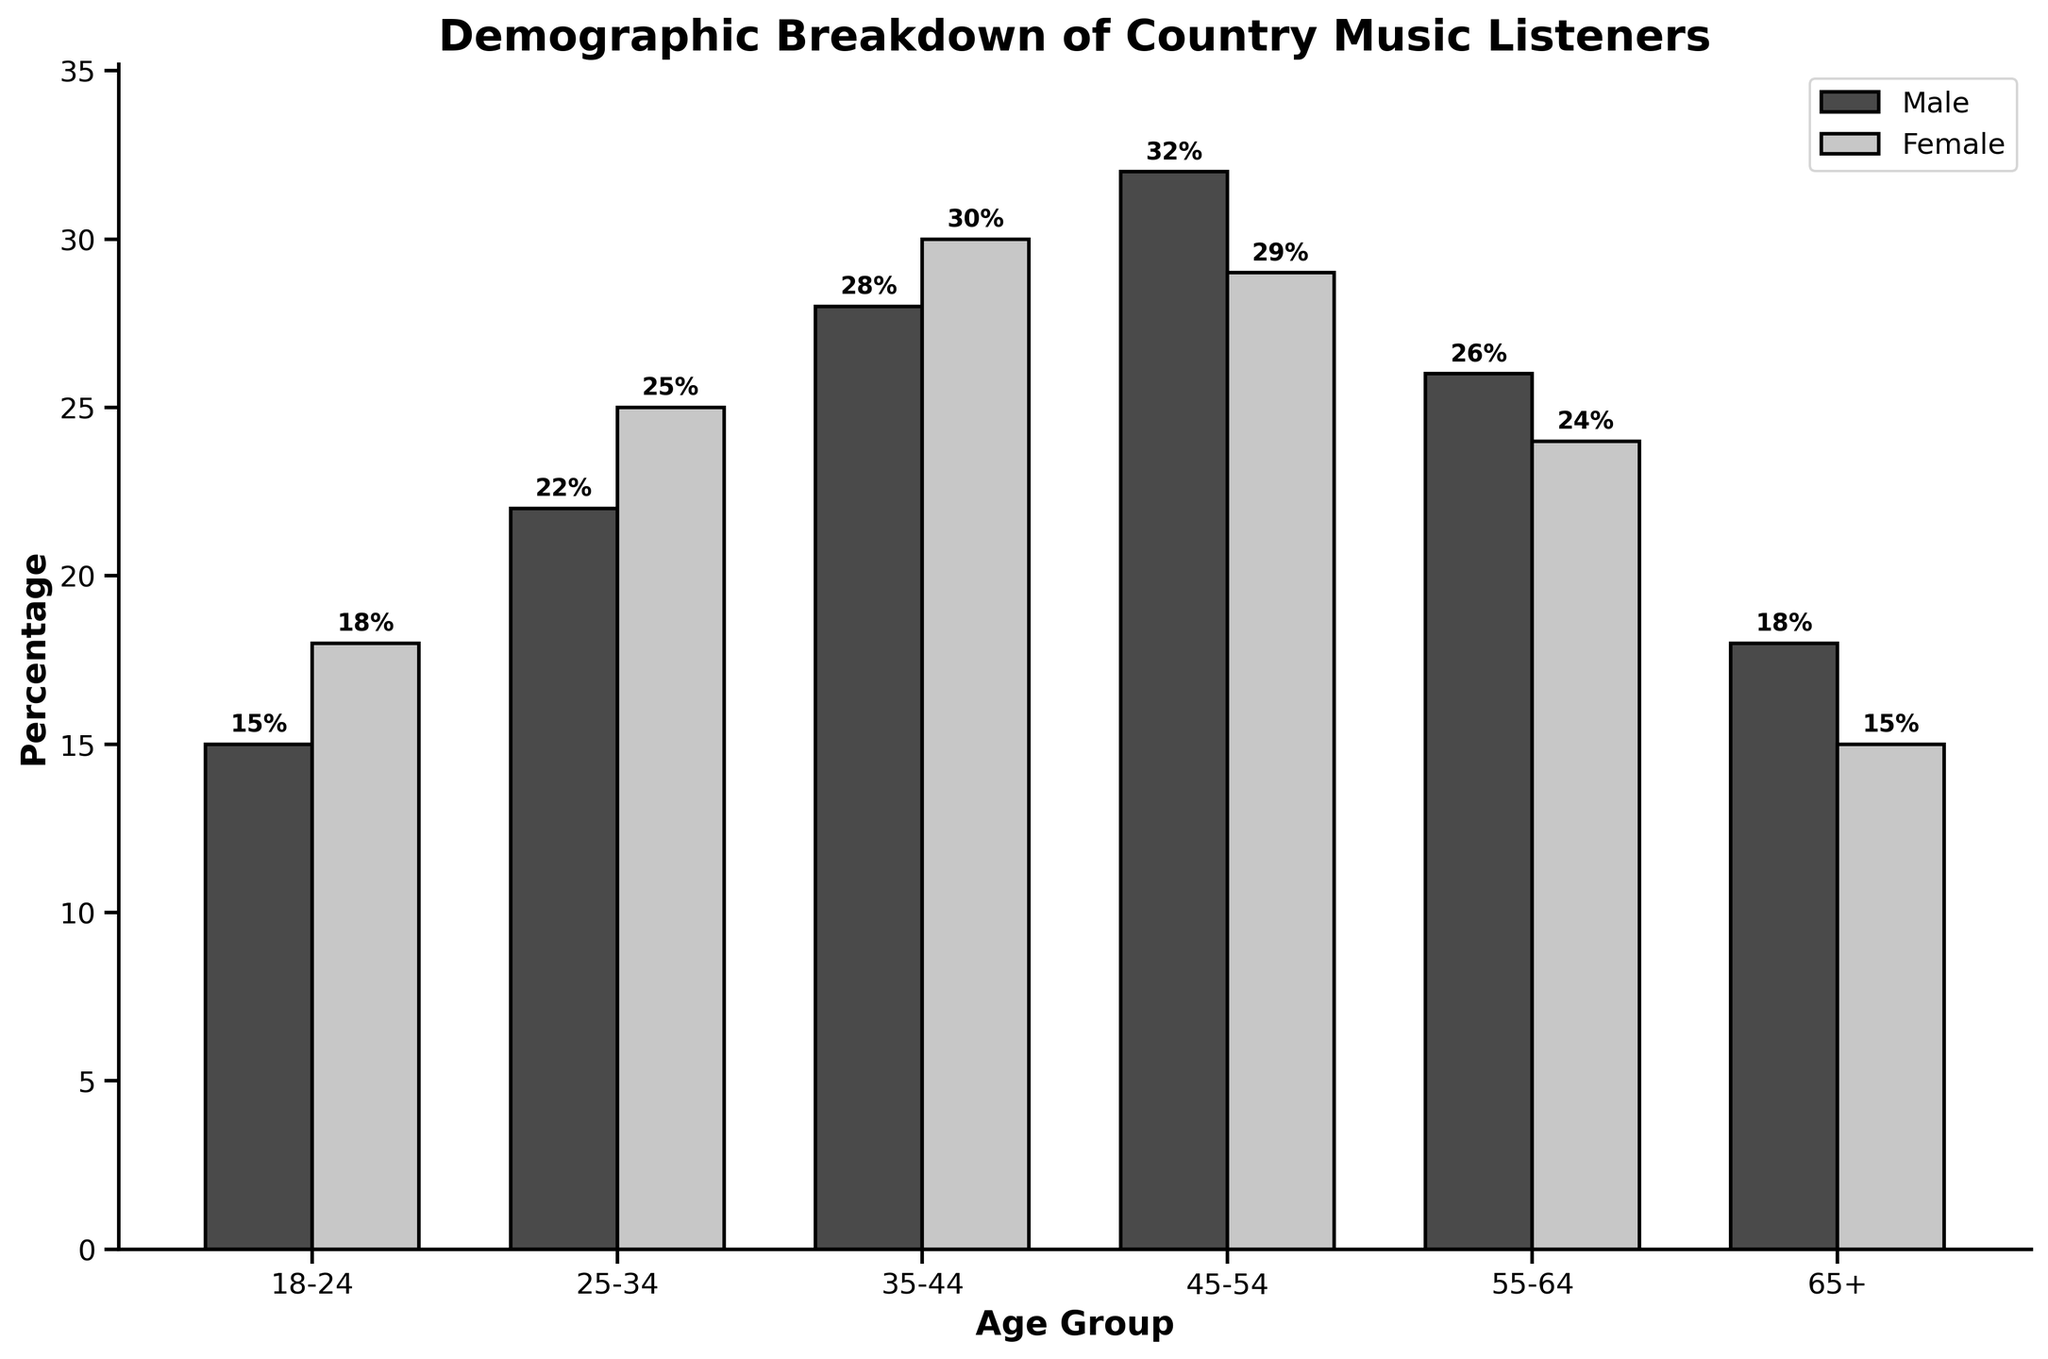How many more male country music listeners are there in the 45-54 age group compared to the 55-64 age group? To find the number of additional male listeners in the 45-54 age group compared to the 55-64 age group, subtract the number of male listeners in the 55-64 age group (26) from the number of male listeners in the 45-54 age group (32).
Answer: 6 Which age group has the highest female country music listener percentage? To determine this, look at the values of the female listeners for each age group. The highest value is 30, corresponding to the 35-44 age group.
Answer: 35-44 What is the average percentage of country music listeners between the ages 18 to 34 for both genders? To find the average, sum the male and female percentages for the 18-24 and 25-34 age groups, then divide by 4. (15+18+22+25) / 4 = 80 / 4.
Answer: 20 Compare the gender distribution in the 35-44 age group, which gender has more listeners and by how much? Take the percentage of female listeners (30) and subtract the percentage of male listeners (28) in the 35-44 age group.
Answer: 2 What is the combined percentage of male and female listeners in the 65+ age group? Add the percentage of male listeners (18) to the percentage of female listeners (15) in the 65+ age group.
Answer: 33 By how much do male listeners in the 45-54 age group exceed female listeners in the same group? Subtract the percentage of female listeners (29) from the percentage of male listeners (32) in the 45-54 age group.
Answer: 3 Which gender has a higher total percentage across all age groups and by how much? Sum the percentages for males (15+22+28+32+26+18) and females (18+25+30+29+24+15). Compare the totals: Males (141) and Females (141).
Answer: Equal; 0 Among the age groups 18-24 and 25-34, which has a greater difference between male and female listeners? Compute the difference between male and female listeners for each age group: (18-15) = 3 for 18-24 and (25-22) = 3 for 25-34.
Answer: Equal; 0 